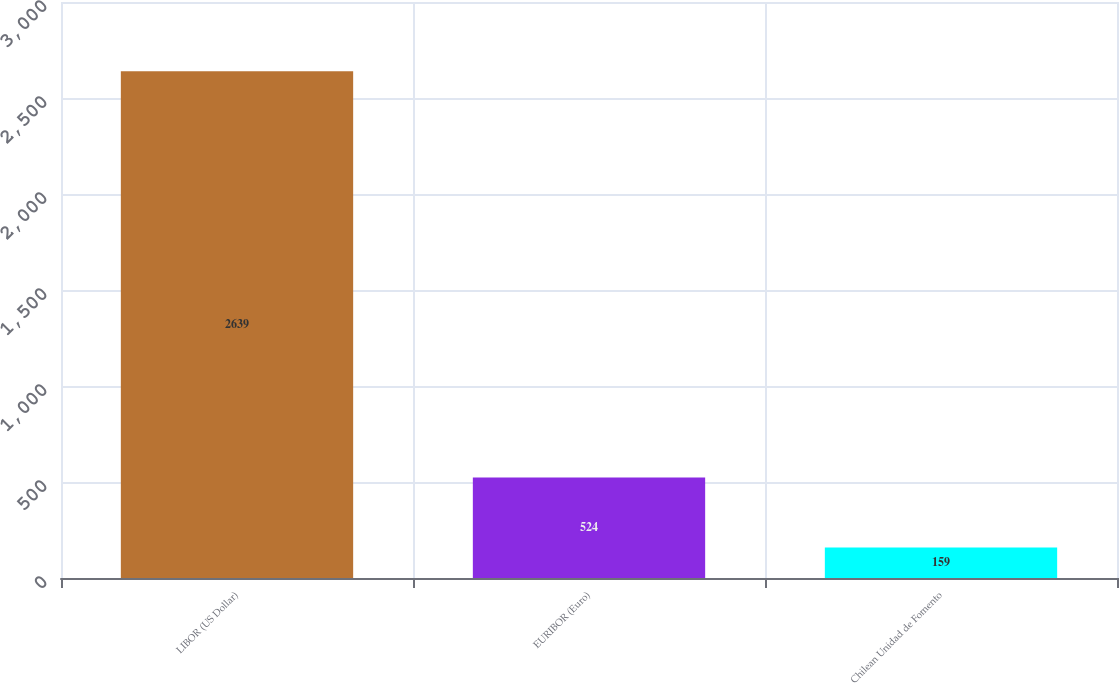Convert chart. <chart><loc_0><loc_0><loc_500><loc_500><bar_chart><fcel>LIBOR (US Dollar)<fcel>EURIBOR (Euro)<fcel>Chilean Unidad de Fomento<nl><fcel>2639<fcel>524<fcel>159<nl></chart> 